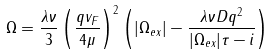Convert formula to latex. <formula><loc_0><loc_0><loc_500><loc_500>\Omega = \frac { \lambda \nu } { 3 } \left ( \frac { q v _ { F } } { 4 \mu } \right ) ^ { 2 } \left ( | \Omega _ { e x } | - \frac { \lambda \nu D q ^ { 2 } } { | \Omega _ { e x } | \tau - i } \right )</formula> 